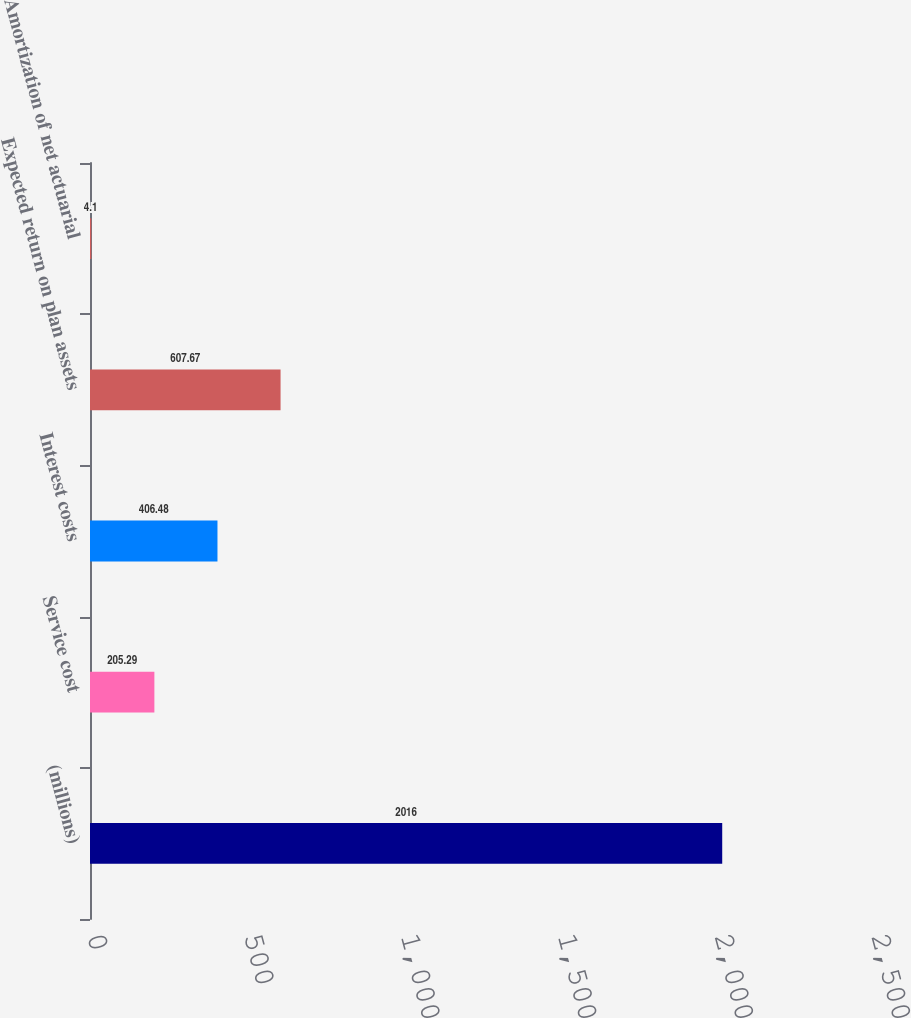Convert chart to OTSL. <chart><loc_0><loc_0><loc_500><loc_500><bar_chart><fcel>(millions)<fcel>Service cost<fcel>Interest costs<fcel>Expected return on plan assets<fcel>Amortization of net actuarial<nl><fcel>2016<fcel>205.29<fcel>406.48<fcel>607.67<fcel>4.1<nl></chart> 